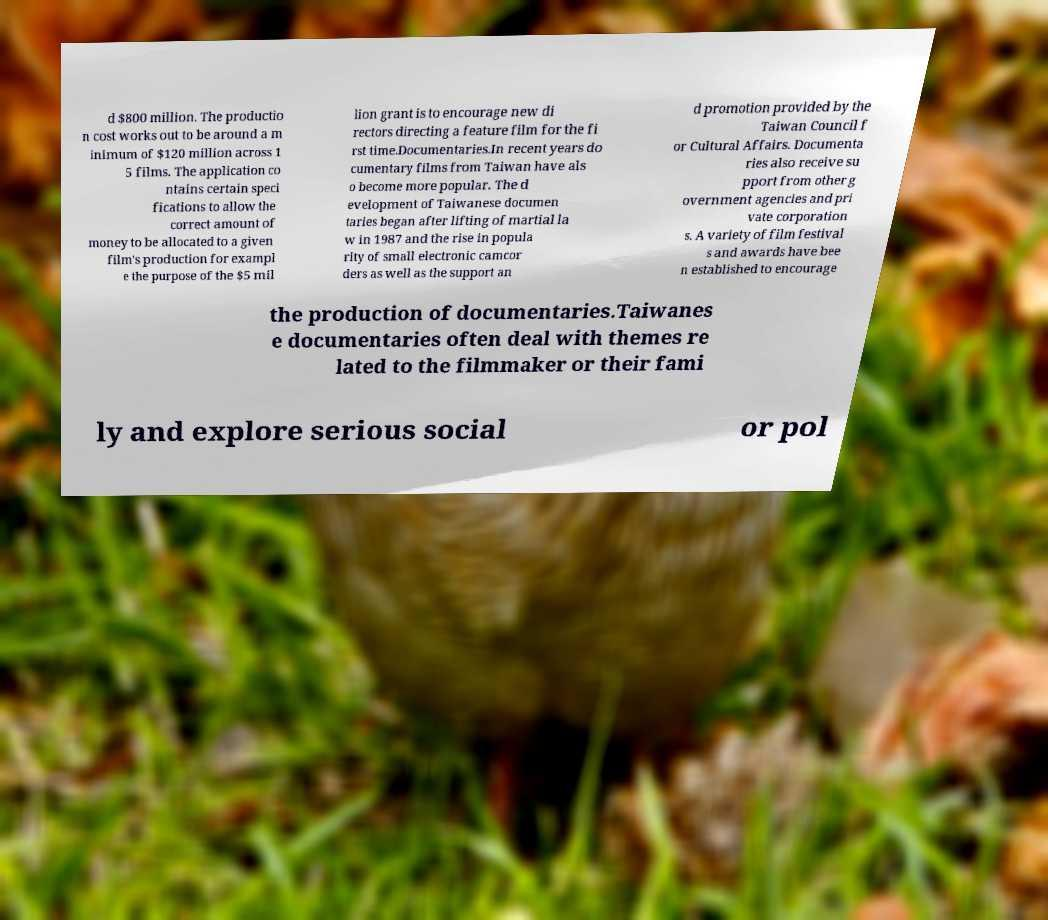Could you assist in decoding the text presented in this image and type it out clearly? d $800 million. The productio n cost works out to be around a m inimum of $120 million across 1 5 films. The application co ntains certain speci fications to allow the correct amount of money to be allocated to a given film's production for exampl e the purpose of the $5 mil lion grant is to encourage new di rectors directing a feature film for the fi rst time.Documentaries.In recent years do cumentary films from Taiwan have als o become more popular. The d evelopment of Taiwanese documen taries began after lifting of martial la w in 1987 and the rise in popula rity of small electronic camcor ders as well as the support an d promotion provided by the Taiwan Council f or Cultural Affairs. Documenta ries also receive su pport from other g overnment agencies and pri vate corporation s. A variety of film festival s and awards have bee n established to encourage the production of documentaries.Taiwanes e documentaries often deal with themes re lated to the filmmaker or their fami ly and explore serious social or pol 